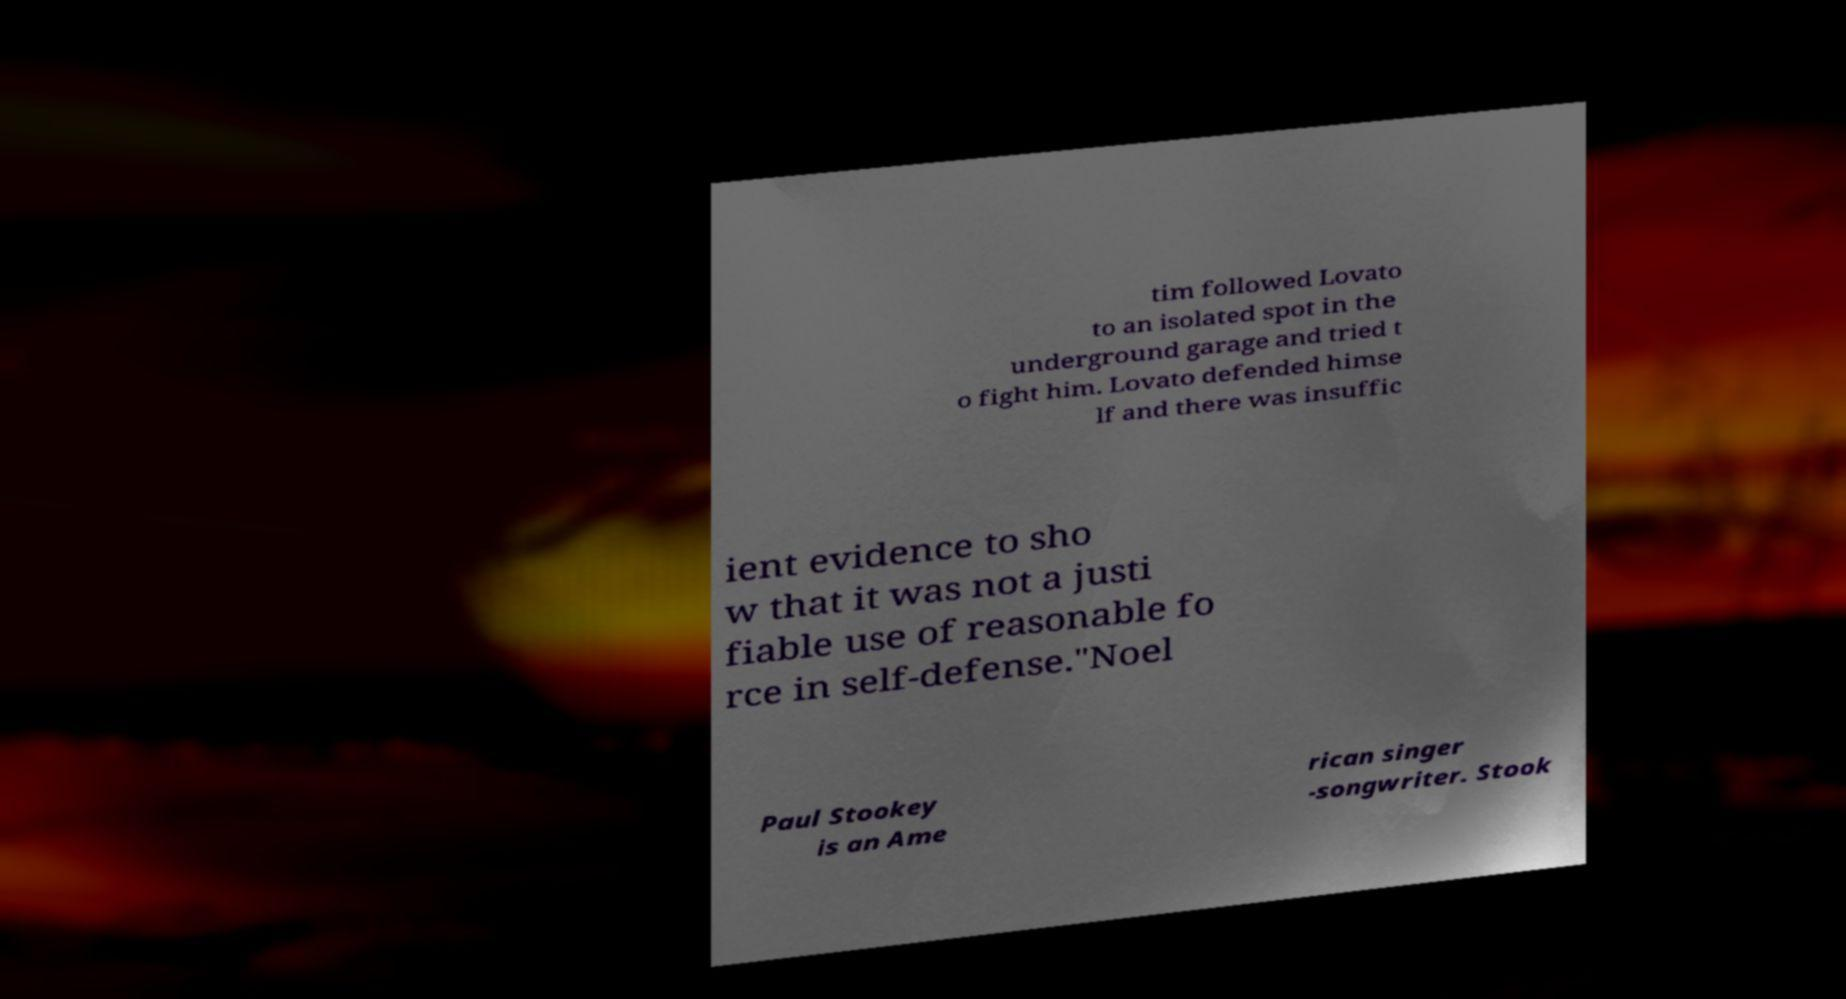For documentation purposes, I need the text within this image transcribed. Could you provide that? tim followed Lovato to an isolated spot in the underground garage and tried t o fight him. Lovato defended himse lf and there was insuffic ient evidence to sho w that it was not a justi fiable use of reasonable fo rce in self-defense."Noel Paul Stookey is an Ame rican singer -songwriter. Stook 